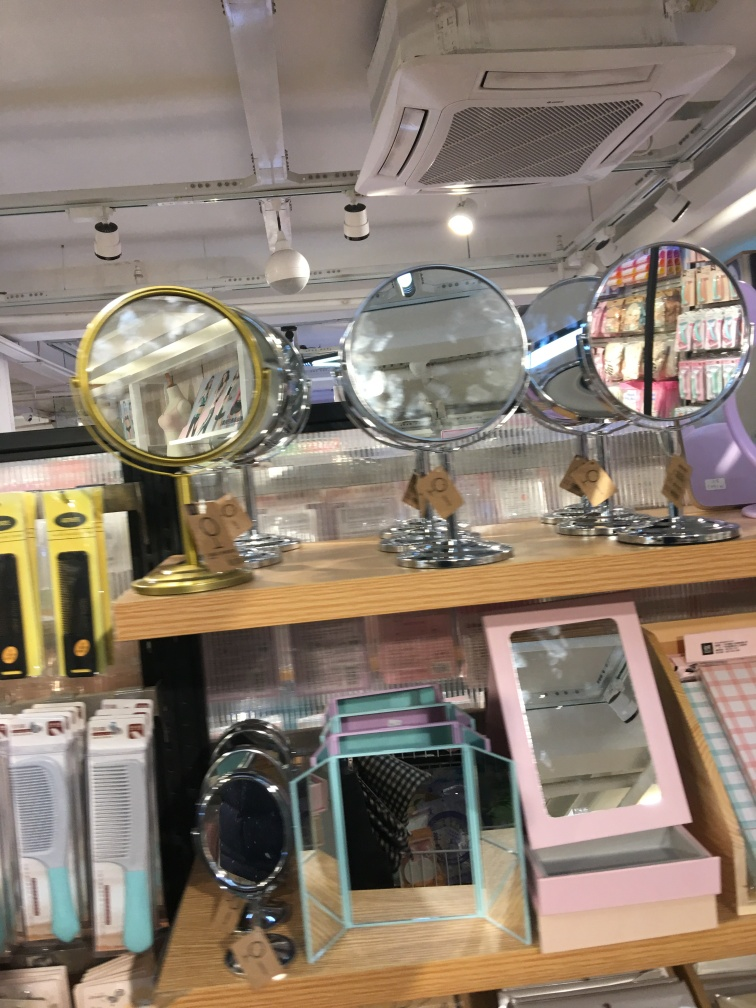Is the overall clarity of the image good? The image is somewhat clear, capturing a variety of mirrors on display in a store. However, the focus could be sharper and the angle of the shot could be improved for a better assessment of the products. 